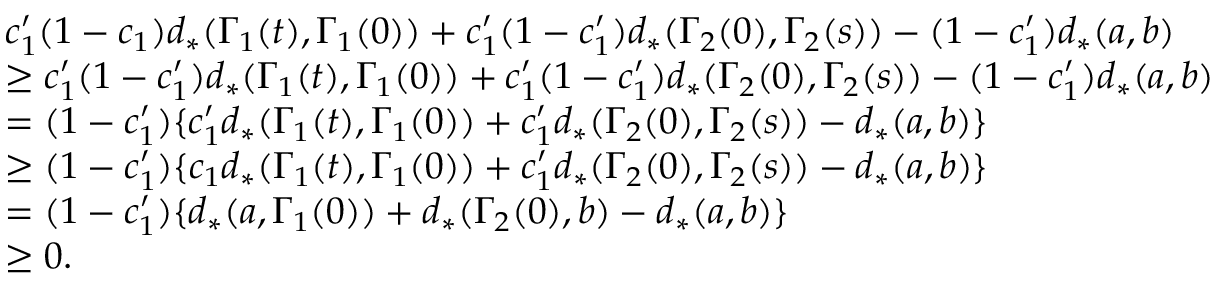Convert formula to latex. <formula><loc_0><loc_0><loc_500><loc_500>\begin{array} { r l } & { c _ { 1 } ^ { \prime } ( 1 - c _ { 1 } ) d _ { * } ( \Gamma _ { 1 } ( t ) , \Gamma _ { 1 } ( 0 ) ) + c _ { 1 } ^ { \prime } ( 1 - c _ { 1 } ^ { \prime } ) d _ { * } ( \Gamma _ { 2 } ( 0 ) , \Gamma _ { 2 } ( s ) ) - ( 1 - c _ { 1 } ^ { \prime } ) d _ { * } ( a , b ) } \\ & { \geq c _ { 1 } ^ { \prime } ( 1 - c _ { 1 } ^ { \prime } ) d _ { * } ( \Gamma _ { 1 } ( t ) , \Gamma _ { 1 } ( 0 ) ) + c _ { 1 } ^ { \prime } ( 1 - c _ { 1 } ^ { \prime } ) d _ { * } ( \Gamma _ { 2 } ( 0 ) , \Gamma _ { 2 } ( s ) ) - ( 1 - c _ { 1 } ^ { \prime } ) d _ { * } ( a , b ) } \\ & { = ( 1 - c _ { 1 } ^ { \prime } ) \{ c _ { 1 } ^ { \prime } d _ { * } ( \Gamma _ { 1 } ( t ) , \Gamma _ { 1 } ( 0 ) ) + c _ { 1 } ^ { \prime } d _ { * } ( \Gamma _ { 2 } ( 0 ) , \Gamma _ { 2 } ( s ) ) - d _ { * } ( a , b ) \} } \\ & { \geq ( 1 - c _ { 1 } ^ { \prime } ) \{ c _ { 1 } d _ { * } ( \Gamma _ { 1 } ( t ) , \Gamma _ { 1 } ( 0 ) ) + c _ { 1 } ^ { \prime } d _ { * } ( \Gamma _ { 2 } ( 0 ) , \Gamma _ { 2 } ( s ) ) - d _ { * } ( a , b ) \} } \\ & { = ( 1 - c _ { 1 } ^ { \prime } ) \{ d _ { * } ( a , \Gamma _ { 1 } ( 0 ) ) + d _ { * } ( \Gamma _ { 2 } ( 0 ) , b ) - d _ { * } ( a , b ) \} } \\ & { \geq 0 . } \end{array}</formula> 